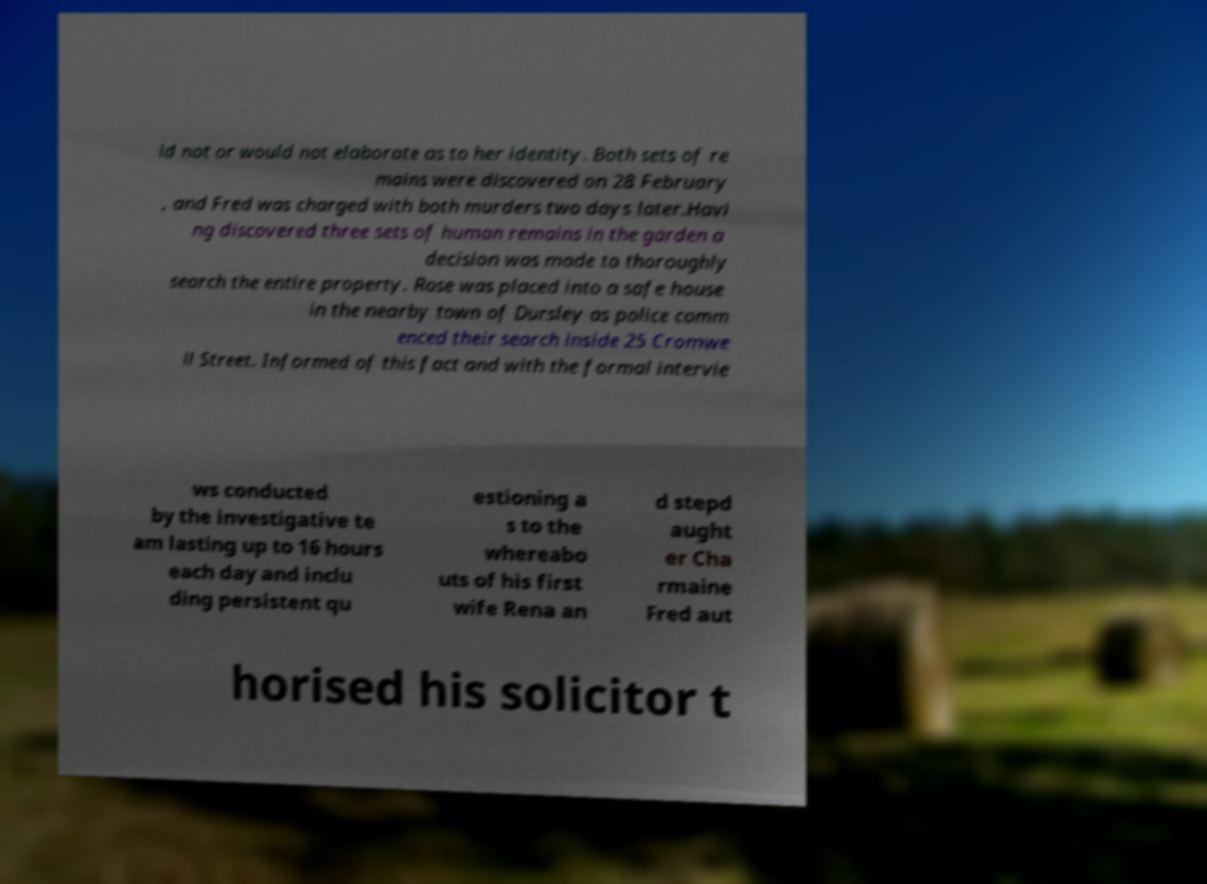Please read and relay the text visible in this image. What does it say? ld not or would not elaborate as to her identity. Both sets of re mains were discovered on 28 February , and Fred was charged with both murders two days later.Havi ng discovered three sets of human remains in the garden a decision was made to thoroughly search the entire property. Rose was placed into a safe house in the nearby town of Dursley as police comm enced their search inside 25 Cromwe ll Street. Informed of this fact and with the formal intervie ws conducted by the investigative te am lasting up to 16 hours each day and inclu ding persistent qu estioning a s to the whereabo uts of his first wife Rena an d stepd aught er Cha rmaine Fred aut horised his solicitor t 